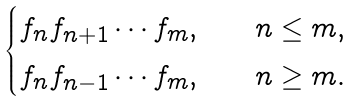<formula> <loc_0><loc_0><loc_500><loc_500>\begin{cases} f _ { n } f _ { n + 1 } \cdots f _ { m } , & \quad n \leq m , \\ f _ { n } f _ { n - 1 } \cdots f _ { m } , & \quad n \geq m . \end{cases}</formula> 